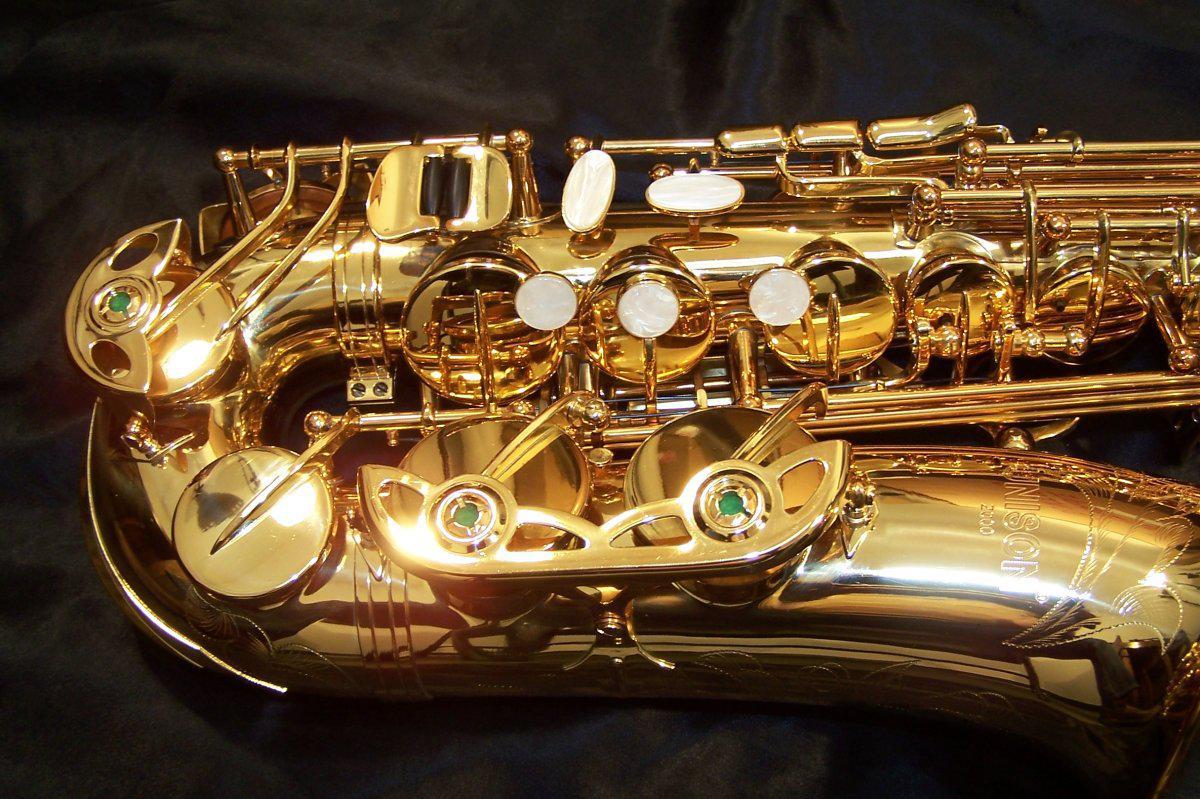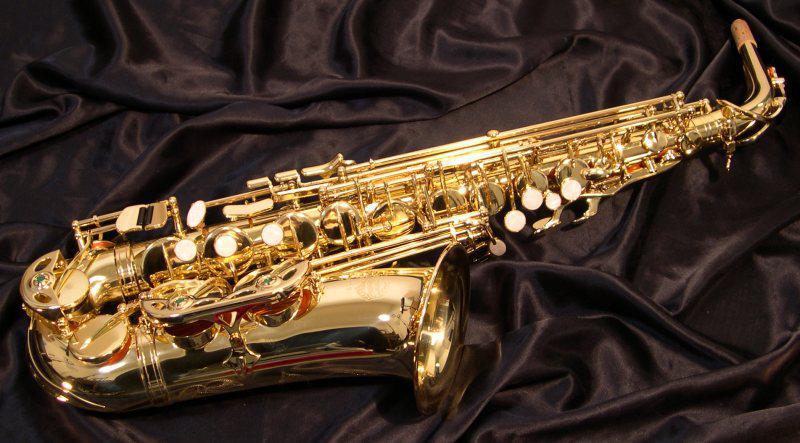The first image is the image on the left, the second image is the image on the right. For the images shown, is this caption "There are at exactly two saxophones in one of the images." true? Answer yes or no. No. The first image is the image on the left, the second image is the image on the right. Evaluate the accuracy of this statement regarding the images: "No image shows more than one saxophone.". Is it true? Answer yes or no. Yes. 